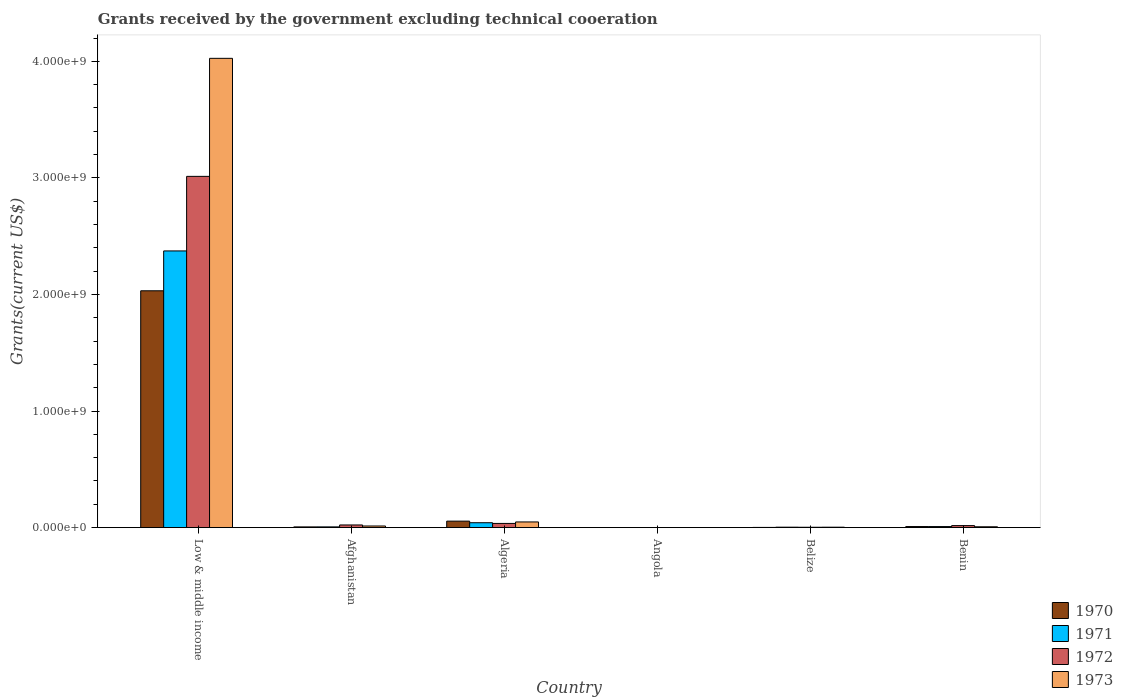How many groups of bars are there?
Ensure brevity in your answer.  6. Are the number of bars per tick equal to the number of legend labels?
Provide a succinct answer. Yes. Are the number of bars on each tick of the X-axis equal?
Your answer should be compact. Yes. How many bars are there on the 3rd tick from the left?
Keep it short and to the point. 4. What is the label of the 3rd group of bars from the left?
Give a very brief answer. Algeria. In how many cases, is the number of bars for a given country not equal to the number of legend labels?
Give a very brief answer. 0. What is the total grants received by the government in 1970 in Belize?
Make the answer very short. 1.77e+06. Across all countries, what is the maximum total grants received by the government in 1972?
Your answer should be compact. 3.01e+09. In which country was the total grants received by the government in 1971 maximum?
Your response must be concise. Low & middle income. In which country was the total grants received by the government in 1971 minimum?
Your answer should be very brief. Angola. What is the total total grants received by the government in 1971 in the graph?
Ensure brevity in your answer.  2.43e+09. What is the difference between the total grants received by the government in 1972 in Angola and that in Benin?
Make the answer very short. -1.73e+07. What is the difference between the total grants received by the government in 1970 in Low & middle income and the total grants received by the government in 1971 in Algeria?
Offer a terse response. 1.99e+09. What is the average total grants received by the government in 1973 per country?
Your answer should be very brief. 6.83e+08. What is the difference between the total grants received by the government of/in 1973 and total grants received by the government of/in 1971 in Belize?
Your response must be concise. -1.30e+05. In how many countries, is the total grants received by the government in 1973 greater than 1000000000 US$?
Offer a terse response. 1. What is the ratio of the total grants received by the government in 1973 in Afghanistan to that in Benin?
Your response must be concise. 1.93. Is the difference between the total grants received by the government in 1973 in Afghanistan and Belize greater than the difference between the total grants received by the government in 1971 in Afghanistan and Belize?
Offer a very short reply. Yes. What is the difference between the highest and the second highest total grants received by the government in 1973?
Your answer should be compact. 4.01e+09. What is the difference between the highest and the lowest total grants received by the government in 1970?
Make the answer very short. 2.03e+09. Is it the case that in every country, the sum of the total grants received by the government in 1973 and total grants received by the government in 1970 is greater than the sum of total grants received by the government in 1972 and total grants received by the government in 1971?
Your response must be concise. No. What does the 3rd bar from the left in Angola represents?
Provide a short and direct response. 1972. Is it the case that in every country, the sum of the total grants received by the government in 1970 and total grants received by the government in 1971 is greater than the total grants received by the government in 1973?
Make the answer very short. No. How many countries are there in the graph?
Your response must be concise. 6. Where does the legend appear in the graph?
Your answer should be compact. Bottom right. How are the legend labels stacked?
Make the answer very short. Vertical. What is the title of the graph?
Your answer should be compact. Grants received by the government excluding technical cooeration. What is the label or title of the Y-axis?
Provide a succinct answer. Grants(current US$). What is the Grants(current US$) of 1970 in Low & middle income?
Your answer should be compact. 2.03e+09. What is the Grants(current US$) of 1971 in Low & middle income?
Make the answer very short. 2.37e+09. What is the Grants(current US$) of 1972 in Low & middle income?
Offer a terse response. 3.01e+09. What is the Grants(current US$) of 1973 in Low & middle income?
Give a very brief answer. 4.03e+09. What is the Grants(current US$) in 1970 in Afghanistan?
Your response must be concise. 6.21e+06. What is the Grants(current US$) of 1971 in Afghanistan?
Your answer should be very brief. 6.32e+06. What is the Grants(current US$) of 1972 in Afghanistan?
Offer a terse response. 2.29e+07. What is the Grants(current US$) of 1973 in Afghanistan?
Your answer should be compact. 1.40e+07. What is the Grants(current US$) of 1970 in Algeria?
Offer a terse response. 5.56e+07. What is the Grants(current US$) in 1971 in Algeria?
Give a very brief answer. 4.21e+07. What is the Grants(current US$) of 1972 in Algeria?
Make the answer very short. 3.60e+07. What is the Grants(current US$) of 1973 in Algeria?
Your response must be concise. 4.88e+07. What is the Grants(current US$) of 1970 in Angola?
Provide a succinct answer. 2.00e+04. What is the Grants(current US$) of 1972 in Angola?
Give a very brief answer. 3.00e+04. What is the Grants(current US$) of 1970 in Belize?
Your answer should be very brief. 1.77e+06. What is the Grants(current US$) of 1971 in Belize?
Offer a terse response. 3.75e+06. What is the Grants(current US$) in 1972 in Belize?
Offer a terse response. 3.09e+06. What is the Grants(current US$) in 1973 in Belize?
Make the answer very short. 3.62e+06. What is the Grants(current US$) in 1970 in Benin?
Provide a short and direct response. 9.23e+06. What is the Grants(current US$) of 1971 in Benin?
Make the answer very short. 9.04e+06. What is the Grants(current US$) of 1972 in Benin?
Your answer should be very brief. 1.73e+07. What is the Grants(current US$) in 1973 in Benin?
Your answer should be very brief. 7.26e+06. Across all countries, what is the maximum Grants(current US$) of 1970?
Your response must be concise. 2.03e+09. Across all countries, what is the maximum Grants(current US$) of 1971?
Your answer should be very brief. 2.37e+09. Across all countries, what is the maximum Grants(current US$) of 1972?
Ensure brevity in your answer.  3.01e+09. Across all countries, what is the maximum Grants(current US$) in 1973?
Ensure brevity in your answer.  4.03e+09. Across all countries, what is the minimum Grants(current US$) of 1971?
Your answer should be very brief. 10000. Across all countries, what is the minimum Grants(current US$) in 1972?
Your answer should be very brief. 3.00e+04. Across all countries, what is the minimum Grants(current US$) of 1973?
Provide a short and direct response. 8.00e+04. What is the total Grants(current US$) in 1970 in the graph?
Your answer should be very brief. 2.10e+09. What is the total Grants(current US$) in 1971 in the graph?
Your answer should be very brief. 2.43e+09. What is the total Grants(current US$) of 1972 in the graph?
Your answer should be compact. 3.09e+09. What is the total Grants(current US$) in 1973 in the graph?
Give a very brief answer. 4.10e+09. What is the difference between the Grants(current US$) in 1970 in Low & middle income and that in Afghanistan?
Keep it short and to the point. 2.03e+09. What is the difference between the Grants(current US$) in 1971 in Low & middle income and that in Afghanistan?
Your response must be concise. 2.37e+09. What is the difference between the Grants(current US$) of 1972 in Low & middle income and that in Afghanistan?
Keep it short and to the point. 2.99e+09. What is the difference between the Grants(current US$) in 1973 in Low & middle income and that in Afghanistan?
Provide a short and direct response. 4.01e+09. What is the difference between the Grants(current US$) in 1970 in Low & middle income and that in Algeria?
Your answer should be very brief. 1.98e+09. What is the difference between the Grants(current US$) of 1971 in Low & middle income and that in Algeria?
Your answer should be compact. 2.33e+09. What is the difference between the Grants(current US$) of 1972 in Low & middle income and that in Algeria?
Ensure brevity in your answer.  2.98e+09. What is the difference between the Grants(current US$) in 1973 in Low & middle income and that in Algeria?
Provide a succinct answer. 3.98e+09. What is the difference between the Grants(current US$) in 1970 in Low & middle income and that in Angola?
Offer a very short reply. 2.03e+09. What is the difference between the Grants(current US$) in 1971 in Low & middle income and that in Angola?
Give a very brief answer. 2.37e+09. What is the difference between the Grants(current US$) in 1972 in Low & middle income and that in Angola?
Your answer should be very brief. 3.01e+09. What is the difference between the Grants(current US$) in 1973 in Low & middle income and that in Angola?
Offer a very short reply. 4.03e+09. What is the difference between the Grants(current US$) in 1970 in Low & middle income and that in Belize?
Provide a succinct answer. 2.03e+09. What is the difference between the Grants(current US$) of 1971 in Low & middle income and that in Belize?
Provide a short and direct response. 2.37e+09. What is the difference between the Grants(current US$) in 1972 in Low & middle income and that in Belize?
Provide a short and direct response. 3.01e+09. What is the difference between the Grants(current US$) in 1973 in Low & middle income and that in Belize?
Keep it short and to the point. 4.02e+09. What is the difference between the Grants(current US$) of 1970 in Low & middle income and that in Benin?
Offer a terse response. 2.02e+09. What is the difference between the Grants(current US$) in 1971 in Low & middle income and that in Benin?
Ensure brevity in your answer.  2.36e+09. What is the difference between the Grants(current US$) in 1972 in Low & middle income and that in Benin?
Ensure brevity in your answer.  3.00e+09. What is the difference between the Grants(current US$) of 1973 in Low & middle income and that in Benin?
Provide a succinct answer. 4.02e+09. What is the difference between the Grants(current US$) in 1970 in Afghanistan and that in Algeria?
Provide a succinct answer. -4.94e+07. What is the difference between the Grants(current US$) in 1971 in Afghanistan and that in Algeria?
Your response must be concise. -3.58e+07. What is the difference between the Grants(current US$) of 1972 in Afghanistan and that in Algeria?
Your answer should be compact. -1.31e+07. What is the difference between the Grants(current US$) of 1973 in Afghanistan and that in Algeria?
Your answer should be compact. -3.47e+07. What is the difference between the Grants(current US$) in 1970 in Afghanistan and that in Angola?
Provide a succinct answer. 6.19e+06. What is the difference between the Grants(current US$) in 1971 in Afghanistan and that in Angola?
Your response must be concise. 6.31e+06. What is the difference between the Grants(current US$) in 1972 in Afghanistan and that in Angola?
Give a very brief answer. 2.29e+07. What is the difference between the Grants(current US$) of 1973 in Afghanistan and that in Angola?
Provide a succinct answer. 1.40e+07. What is the difference between the Grants(current US$) in 1970 in Afghanistan and that in Belize?
Provide a short and direct response. 4.44e+06. What is the difference between the Grants(current US$) in 1971 in Afghanistan and that in Belize?
Offer a very short reply. 2.57e+06. What is the difference between the Grants(current US$) in 1972 in Afghanistan and that in Belize?
Make the answer very short. 1.98e+07. What is the difference between the Grants(current US$) in 1973 in Afghanistan and that in Belize?
Your answer should be very brief. 1.04e+07. What is the difference between the Grants(current US$) of 1970 in Afghanistan and that in Benin?
Your answer should be very brief. -3.02e+06. What is the difference between the Grants(current US$) in 1971 in Afghanistan and that in Benin?
Provide a succinct answer. -2.72e+06. What is the difference between the Grants(current US$) in 1972 in Afghanistan and that in Benin?
Offer a very short reply. 5.57e+06. What is the difference between the Grants(current US$) in 1973 in Afghanistan and that in Benin?
Your answer should be very brief. 6.78e+06. What is the difference between the Grants(current US$) in 1970 in Algeria and that in Angola?
Your answer should be very brief. 5.56e+07. What is the difference between the Grants(current US$) of 1971 in Algeria and that in Angola?
Offer a very short reply. 4.21e+07. What is the difference between the Grants(current US$) in 1972 in Algeria and that in Angola?
Offer a terse response. 3.59e+07. What is the difference between the Grants(current US$) of 1973 in Algeria and that in Angola?
Offer a very short reply. 4.87e+07. What is the difference between the Grants(current US$) of 1970 in Algeria and that in Belize?
Make the answer very short. 5.38e+07. What is the difference between the Grants(current US$) of 1971 in Algeria and that in Belize?
Provide a succinct answer. 3.83e+07. What is the difference between the Grants(current US$) in 1972 in Algeria and that in Belize?
Your answer should be compact. 3.29e+07. What is the difference between the Grants(current US$) of 1973 in Algeria and that in Belize?
Keep it short and to the point. 4.52e+07. What is the difference between the Grants(current US$) of 1970 in Algeria and that in Benin?
Offer a very short reply. 4.64e+07. What is the difference between the Grants(current US$) in 1971 in Algeria and that in Benin?
Give a very brief answer. 3.30e+07. What is the difference between the Grants(current US$) in 1972 in Algeria and that in Benin?
Offer a terse response. 1.86e+07. What is the difference between the Grants(current US$) of 1973 in Algeria and that in Benin?
Offer a very short reply. 4.15e+07. What is the difference between the Grants(current US$) of 1970 in Angola and that in Belize?
Offer a terse response. -1.75e+06. What is the difference between the Grants(current US$) in 1971 in Angola and that in Belize?
Offer a terse response. -3.74e+06. What is the difference between the Grants(current US$) in 1972 in Angola and that in Belize?
Ensure brevity in your answer.  -3.06e+06. What is the difference between the Grants(current US$) of 1973 in Angola and that in Belize?
Provide a short and direct response. -3.54e+06. What is the difference between the Grants(current US$) of 1970 in Angola and that in Benin?
Ensure brevity in your answer.  -9.21e+06. What is the difference between the Grants(current US$) of 1971 in Angola and that in Benin?
Provide a short and direct response. -9.03e+06. What is the difference between the Grants(current US$) in 1972 in Angola and that in Benin?
Keep it short and to the point. -1.73e+07. What is the difference between the Grants(current US$) in 1973 in Angola and that in Benin?
Your response must be concise. -7.18e+06. What is the difference between the Grants(current US$) of 1970 in Belize and that in Benin?
Provide a succinct answer. -7.46e+06. What is the difference between the Grants(current US$) of 1971 in Belize and that in Benin?
Make the answer very short. -5.29e+06. What is the difference between the Grants(current US$) of 1972 in Belize and that in Benin?
Give a very brief answer. -1.42e+07. What is the difference between the Grants(current US$) of 1973 in Belize and that in Benin?
Provide a succinct answer. -3.64e+06. What is the difference between the Grants(current US$) of 1970 in Low & middle income and the Grants(current US$) of 1971 in Afghanistan?
Give a very brief answer. 2.03e+09. What is the difference between the Grants(current US$) of 1970 in Low & middle income and the Grants(current US$) of 1972 in Afghanistan?
Your answer should be very brief. 2.01e+09. What is the difference between the Grants(current US$) of 1970 in Low & middle income and the Grants(current US$) of 1973 in Afghanistan?
Give a very brief answer. 2.02e+09. What is the difference between the Grants(current US$) of 1971 in Low & middle income and the Grants(current US$) of 1972 in Afghanistan?
Give a very brief answer. 2.35e+09. What is the difference between the Grants(current US$) of 1971 in Low & middle income and the Grants(current US$) of 1973 in Afghanistan?
Ensure brevity in your answer.  2.36e+09. What is the difference between the Grants(current US$) in 1972 in Low & middle income and the Grants(current US$) in 1973 in Afghanistan?
Your answer should be very brief. 3.00e+09. What is the difference between the Grants(current US$) in 1970 in Low & middle income and the Grants(current US$) in 1971 in Algeria?
Keep it short and to the point. 1.99e+09. What is the difference between the Grants(current US$) in 1970 in Low & middle income and the Grants(current US$) in 1972 in Algeria?
Make the answer very short. 2.00e+09. What is the difference between the Grants(current US$) of 1970 in Low & middle income and the Grants(current US$) of 1973 in Algeria?
Ensure brevity in your answer.  1.98e+09. What is the difference between the Grants(current US$) in 1971 in Low & middle income and the Grants(current US$) in 1972 in Algeria?
Your response must be concise. 2.34e+09. What is the difference between the Grants(current US$) in 1971 in Low & middle income and the Grants(current US$) in 1973 in Algeria?
Ensure brevity in your answer.  2.32e+09. What is the difference between the Grants(current US$) of 1972 in Low & middle income and the Grants(current US$) of 1973 in Algeria?
Your answer should be compact. 2.96e+09. What is the difference between the Grants(current US$) in 1970 in Low & middle income and the Grants(current US$) in 1971 in Angola?
Provide a succinct answer. 2.03e+09. What is the difference between the Grants(current US$) in 1970 in Low & middle income and the Grants(current US$) in 1972 in Angola?
Your response must be concise. 2.03e+09. What is the difference between the Grants(current US$) in 1970 in Low & middle income and the Grants(current US$) in 1973 in Angola?
Give a very brief answer. 2.03e+09. What is the difference between the Grants(current US$) in 1971 in Low & middle income and the Grants(current US$) in 1972 in Angola?
Offer a very short reply. 2.37e+09. What is the difference between the Grants(current US$) of 1971 in Low & middle income and the Grants(current US$) of 1973 in Angola?
Your answer should be very brief. 2.37e+09. What is the difference between the Grants(current US$) of 1972 in Low & middle income and the Grants(current US$) of 1973 in Angola?
Your answer should be compact. 3.01e+09. What is the difference between the Grants(current US$) in 1970 in Low & middle income and the Grants(current US$) in 1971 in Belize?
Your answer should be compact. 2.03e+09. What is the difference between the Grants(current US$) in 1970 in Low & middle income and the Grants(current US$) in 1972 in Belize?
Keep it short and to the point. 2.03e+09. What is the difference between the Grants(current US$) of 1970 in Low & middle income and the Grants(current US$) of 1973 in Belize?
Give a very brief answer. 2.03e+09. What is the difference between the Grants(current US$) of 1971 in Low & middle income and the Grants(current US$) of 1972 in Belize?
Ensure brevity in your answer.  2.37e+09. What is the difference between the Grants(current US$) of 1971 in Low & middle income and the Grants(current US$) of 1973 in Belize?
Your response must be concise. 2.37e+09. What is the difference between the Grants(current US$) in 1972 in Low & middle income and the Grants(current US$) in 1973 in Belize?
Your answer should be compact. 3.01e+09. What is the difference between the Grants(current US$) of 1970 in Low & middle income and the Grants(current US$) of 1971 in Benin?
Provide a short and direct response. 2.02e+09. What is the difference between the Grants(current US$) in 1970 in Low & middle income and the Grants(current US$) in 1972 in Benin?
Your response must be concise. 2.01e+09. What is the difference between the Grants(current US$) in 1970 in Low & middle income and the Grants(current US$) in 1973 in Benin?
Provide a short and direct response. 2.02e+09. What is the difference between the Grants(current US$) in 1971 in Low & middle income and the Grants(current US$) in 1972 in Benin?
Your answer should be very brief. 2.36e+09. What is the difference between the Grants(current US$) of 1971 in Low & middle income and the Grants(current US$) of 1973 in Benin?
Offer a very short reply. 2.37e+09. What is the difference between the Grants(current US$) in 1972 in Low & middle income and the Grants(current US$) in 1973 in Benin?
Offer a very short reply. 3.01e+09. What is the difference between the Grants(current US$) of 1970 in Afghanistan and the Grants(current US$) of 1971 in Algeria?
Offer a very short reply. -3.59e+07. What is the difference between the Grants(current US$) in 1970 in Afghanistan and the Grants(current US$) in 1972 in Algeria?
Your answer should be very brief. -2.98e+07. What is the difference between the Grants(current US$) of 1970 in Afghanistan and the Grants(current US$) of 1973 in Algeria?
Your answer should be very brief. -4.26e+07. What is the difference between the Grants(current US$) of 1971 in Afghanistan and the Grants(current US$) of 1972 in Algeria?
Give a very brief answer. -2.96e+07. What is the difference between the Grants(current US$) of 1971 in Afghanistan and the Grants(current US$) of 1973 in Algeria?
Your answer should be very brief. -4.24e+07. What is the difference between the Grants(current US$) of 1972 in Afghanistan and the Grants(current US$) of 1973 in Algeria?
Offer a terse response. -2.59e+07. What is the difference between the Grants(current US$) of 1970 in Afghanistan and the Grants(current US$) of 1971 in Angola?
Offer a terse response. 6.20e+06. What is the difference between the Grants(current US$) in 1970 in Afghanistan and the Grants(current US$) in 1972 in Angola?
Provide a short and direct response. 6.18e+06. What is the difference between the Grants(current US$) in 1970 in Afghanistan and the Grants(current US$) in 1973 in Angola?
Your response must be concise. 6.13e+06. What is the difference between the Grants(current US$) of 1971 in Afghanistan and the Grants(current US$) of 1972 in Angola?
Ensure brevity in your answer.  6.29e+06. What is the difference between the Grants(current US$) of 1971 in Afghanistan and the Grants(current US$) of 1973 in Angola?
Give a very brief answer. 6.24e+06. What is the difference between the Grants(current US$) of 1972 in Afghanistan and the Grants(current US$) of 1973 in Angola?
Give a very brief answer. 2.28e+07. What is the difference between the Grants(current US$) in 1970 in Afghanistan and the Grants(current US$) in 1971 in Belize?
Keep it short and to the point. 2.46e+06. What is the difference between the Grants(current US$) in 1970 in Afghanistan and the Grants(current US$) in 1972 in Belize?
Your answer should be very brief. 3.12e+06. What is the difference between the Grants(current US$) of 1970 in Afghanistan and the Grants(current US$) of 1973 in Belize?
Offer a very short reply. 2.59e+06. What is the difference between the Grants(current US$) in 1971 in Afghanistan and the Grants(current US$) in 1972 in Belize?
Provide a succinct answer. 3.23e+06. What is the difference between the Grants(current US$) in 1971 in Afghanistan and the Grants(current US$) in 1973 in Belize?
Provide a succinct answer. 2.70e+06. What is the difference between the Grants(current US$) in 1972 in Afghanistan and the Grants(current US$) in 1973 in Belize?
Offer a very short reply. 1.93e+07. What is the difference between the Grants(current US$) in 1970 in Afghanistan and the Grants(current US$) in 1971 in Benin?
Provide a short and direct response. -2.83e+06. What is the difference between the Grants(current US$) of 1970 in Afghanistan and the Grants(current US$) of 1972 in Benin?
Make the answer very short. -1.11e+07. What is the difference between the Grants(current US$) of 1970 in Afghanistan and the Grants(current US$) of 1973 in Benin?
Your response must be concise. -1.05e+06. What is the difference between the Grants(current US$) in 1971 in Afghanistan and the Grants(current US$) in 1972 in Benin?
Keep it short and to the point. -1.10e+07. What is the difference between the Grants(current US$) of 1971 in Afghanistan and the Grants(current US$) of 1973 in Benin?
Give a very brief answer. -9.40e+05. What is the difference between the Grants(current US$) of 1972 in Afghanistan and the Grants(current US$) of 1973 in Benin?
Keep it short and to the point. 1.56e+07. What is the difference between the Grants(current US$) of 1970 in Algeria and the Grants(current US$) of 1971 in Angola?
Make the answer very short. 5.56e+07. What is the difference between the Grants(current US$) in 1970 in Algeria and the Grants(current US$) in 1972 in Angola?
Give a very brief answer. 5.56e+07. What is the difference between the Grants(current US$) in 1970 in Algeria and the Grants(current US$) in 1973 in Angola?
Make the answer very short. 5.55e+07. What is the difference between the Grants(current US$) in 1971 in Algeria and the Grants(current US$) in 1972 in Angola?
Your response must be concise. 4.20e+07. What is the difference between the Grants(current US$) in 1971 in Algeria and the Grants(current US$) in 1973 in Angola?
Your response must be concise. 4.20e+07. What is the difference between the Grants(current US$) of 1972 in Algeria and the Grants(current US$) of 1973 in Angola?
Your answer should be very brief. 3.59e+07. What is the difference between the Grants(current US$) in 1970 in Algeria and the Grants(current US$) in 1971 in Belize?
Keep it short and to the point. 5.19e+07. What is the difference between the Grants(current US$) of 1970 in Algeria and the Grants(current US$) of 1972 in Belize?
Keep it short and to the point. 5.25e+07. What is the difference between the Grants(current US$) of 1970 in Algeria and the Grants(current US$) of 1973 in Belize?
Keep it short and to the point. 5.20e+07. What is the difference between the Grants(current US$) of 1971 in Algeria and the Grants(current US$) of 1972 in Belize?
Give a very brief answer. 3.90e+07. What is the difference between the Grants(current US$) in 1971 in Algeria and the Grants(current US$) in 1973 in Belize?
Ensure brevity in your answer.  3.85e+07. What is the difference between the Grants(current US$) in 1972 in Algeria and the Grants(current US$) in 1973 in Belize?
Offer a very short reply. 3.23e+07. What is the difference between the Grants(current US$) of 1970 in Algeria and the Grants(current US$) of 1971 in Benin?
Give a very brief answer. 4.66e+07. What is the difference between the Grants(current US$) in 1970 in Algeria and the Grants(current US$) in 1972 in Benin?
Your response must be concise. 3.83e+07. What is the difference between the Grants(current US$) in 1970 in Algeria and the Grants(current US$) in 1973 in Benin?
Provide a succinct answer. 4.84e+07. What is the difference between the Grants(current US$) in 1971 in Algeria and the Grants(current US$) in 1972 in Benin?
Provide a succinct answer. 2.48e+07. What is the difference between the Grants(current US$) in 1971 in Algeria and the Grants(current US$) in 1973 in Benin?
Ensure brevity in your answer.  3.48e+07. What is the difference between the Grants(current US$) of 1972 in Algeria and the Grants(current US$) of 1973 in Benin?
Your response must be concise. 2.87e+07. What is the difference between the Grants(current US$) in 1970 in Angola and the Grants(current US$) in 1971 in Belize?
Give a very brief answer. -3.73e+06. What is the difference between the Grants(current US$) in 1970 in Angola and the Grants(current US$) in 1972 in Belize?
Your answer should be compact. -3.07e+06. What is the difference between the Grants(current US$) of 1970 in Angola and the Grants(current US$) of 1973 in Belize?
Provide a short and direct response. -3.60e+06. What is the difference between the Grants(current US$) of 1971 in Angola and the Grants(current US$) of 1972 in Belize?
Give a very brief answer. -3.08e+06. What is the difference between the Grants(current US$) of 1971 in Angola and the Grants(current US$) of 1973 in Belize?
Ensure brevity in your answer.  -3.61e+06. What is the difference between the Grants(current US$) in 1972 in Angola and the Grants(current US$) in 1973 in Belize?
Provide a short and direct response. -3.59e+06. What is the difference between the Grants(current US$) in 1970 in Angola and the Grants(current US$) in 1971 in Benin?
Provide a short and direct response. -9.02e+06. What is the difference between the Grants(current US$) in 1970 in Angola and the Grants(current US$) in 1972 in Benin?
Offer a very short reply. -1.73e+07. What is the difference between the Grants(current US$) of 1970 in Angola and the Grants(current US$) of 1973 in Benin?
Your answer should be very brief. -7.24e+06. What is the difference between the Grants(current US$) in 1971 in Angola and the Grants(current US$) in 1972 in Benin?
Provide a short and direct response. -1.73e+07. What is the difference between the Grants(current US$) of 1971 in Angola and the Grants(current US$) of 1973 in Benin?
Provide a short and direct response. -7.25e+06. What is the difference between the Grants(current US$) in 1972 in Angola and the Grants(current US$) in 1973 in Benin?
Your answer should be very brief. -7.23e+06. What is the difference between the Grants(current US$) in 1970 in Belize and the Grants(current US$) in 1971 in Benin?
Give a very brief answer. -7.27e+06. What is the difference between the Grants(current US$) of 1970 in Belize and the Grants(current US$) of 1972 in Benin?
Provide a succinct answer. -1.56e+07. What is the difference between the Grants(current US$) of 1970 in Belize and the Grants(current US$) of 1973 in Benin?
Give a very brief answer. -5.49e+06. What is the difference between the Grants(current US$) in 1971 in Belize and the Grants(current US$) in 1972 in Benin?
Your answer should be very brief. -1.36e+07. What is the difference between the Grants(current US$) of 1971 in Belize and the Grants(current US$) of 1973 in Benin?
Your response must be concise. -3.51e+06. What is the difference between the Grants(current US$) in 1972 in Belize and the Grants(current US$) in 1973 in Benin?
Give a very brief answer. -4.17e+06. What is the average Grants(current US$) in 1970 per country?
Your answer should be compact. 3.51e+08. What is the average Grants(current US$) of 1971 per country?
Offer a very short reply. 4.06e+08. What is the average Grants(current US$) in 1972 per country?
Give a very brief answer. 5.15e+08. What is the average Grants(current US$) in 1973 per country?
Your answer should be very brief. 6.83e+08. What is the difference between the Grants(current US$) of 1970 and Grants(current US$) of 1971 in Low & middle income?
Ensure brevity in your answer.  -3.42e+08. What is the difference between the Grants(current US$) of 1970 and Grants(current US$) of 1972 in Low & middle income?
Your response must be concise. -9.82e+08. What is the difference between the Grants(current US$) of 1970 and Grants(current US$) of 1973 in Low & middle income?
Ensure brevity in your answer.  -1.99e+09. What is the difference between the Grants(current US$) of 1971 and Grants(current US$) of 1972 in Low & middle income?
Keep it short and to the point. -6.40e+08. What is the difference between the Grants(current US$) of 1971 and Grants(current US$) of 1973 in Low & middle income?
Your answer should be very brief. -1.65e+09. What is the difference between the Grants(current US$) of 1972 and Grants(current US$) of 1973 in Low & middle income?
Ensure brevity in your answer.  -1.01e+09. What is the difference between the Grants(current US$) of 1970 and Grants(current US$) of 1971 in Afghanistan?
Provide a short and direct response. -1.10e+05. What is the difference between the Grants(current US$) in 1970 and Grants(current US$) in 1972 in Afghanistan?
Offer a terse response. -1.67e+07. What is the difference between the Grants(current US$) in 1970 and Grants(current US$) in 1973 in Afghanistan?
Ensure brevity in your answer.  -7.83e+06. What is the difference between the Grants(current US$) in 1971 and Grants(current US$) in 1972 in Afghanistan?
Keep it short and to the point. -1.66e+07. What is the difference between the Grants(current US$) of 1971 and Grants(current US$) of 1973 in Afghanistan?
Keep it short and to the point. -7.72e+06. What is the difference between the Grants(current US$) of 1972 and Grants(current US$) of 1973 in Afghanistan?
Provide a short and direct response. 8.85e+06. What is the difference between the Grants(current US$) in 1970 and Grants(current US$) in 1971 in Algeria?
Your answer should be very brief. 1.35e+07. What is the difference between the Grants(current US$) of 1970 and Grants(current US$) of 1972 in Algeria?
Your answer should be very brief. 1.97e+07. What is the difference between the Grants(current US$) of 1970 and Grants(current US$) of 1973 in Algeria?
Give a very brief answer. 6.85e+06. What is the difference between the Grants(current US$) in 1971 and Grants(current US$) in 1972 in Algeria?
Provide a short and direct response. 6.12e+06. What is the difference between the Grants(current US$) of 1971 and Grants(current US$) of 1973 in Algeria?
Keep it short and to the point. -6.69e+06. What is the difference between the Grants(current US$) in 1972 and Grants(current US$) in 1973 in Algeria?
Keep it short and to the point. -1.28e+07. What is the difference between the Grants(current US$) of 1970 and Grants(current US$) of 1971 in Angola?
Your response must be concise. 10000. What is the difference between the Grants(current US$) in 1970 and Grants(current US$) in 1972 in Angola?
Give a very brief answer. -10000. What is the difference between the Grants(current US$) in 1970 and Grants(current US$) in 1973 in Angola?
Give a very brief answer. -6.00e+04. What is the difference between the Grants(current US$) of 1971 and Grants(current US$) of 1972 in Angola?
Provide a succinct answer. -2.00e+04. What is the difference between the Grants(current US$) of 1971 and Grants(current US$) of 1973 in Angola?
Offer a very short reply. -7.00e+04. What is the difference between the Grants(current US$) in 1972 and Grants(current US$) in 1973 in Angola?
Make the answer very short. -5.00e+04. What is the difference between the Grants(current US$) in 1970 and Grants(current US$) in 1971 in Belize?
Ensure brevity in your answer.  -1.98e+06. What is the difference between the Grants(current US$) of 1970 and Grants(current US$) of 1972 in Belize?
Your answer should be very brief. -1.32e+06. What is the difference between the Grants(current US$) of 1970 and Grants(current US$) of 1973 in Belize?
Provide a succinct answer. -1.85e+06. What is the difference between the Grants(current US$) of 1971 and Grants(current US$) of 1973 in Belize?
Give a very brief answer. 1.30e+05. What is the difference between the Grants(current US$) of 1972 and Grants(current US$) of 1973 in Belize?
Make the answer very short. -5.30e+05. What is the difference between the Grants(current US$) in 1970 and Grants(current US$) in 1972 in Benin?
Offer a very short reply. -8.09e+06. What is the difference between the Grants(current US$) of 1970 and Grants(current US$) of 1973 in Benin?
Provide a succinct answer. 1.97e+06. What is the difference between the Grants(current US$) in 1971 and Grants(current US$) in 1972 in Benin?
Ensure brevity in your answer.  -8.28e+06. What is the difference between the Grants(current US$) of 1971 and Grants(current US$) of 1973 in Benin?
Ensure brevity in your answer.  1.78e+06. What is the difference between the Grants(current US$) of 1972 and Grants(current US$) of 1973 in Benin?
Ensure brevity in your answer.  1.01e+07. What is the ratio of the Grants(current US$) in 1970 in Low & middle income to that in Afghanistan?
Your response must be concise. 327.15. What is the ratio of the Grants(current US$) of 1971 in Low & middle income to that in Afghanistan?
Provide a short and direct response. 375.56. What is the ratio of the Grants(current US$) of 1972 in Low & middle income to that in Afghanistan?
Ensure brevity in your answer.  131.64. What is the ratio of the Grants(current US$) of 1973 in Low & middle income to that in Afghanistan?
Your response must be concise. 286.73. What is the ratio of the Grants(current US$) of 1970 in Low & middle income to that in Algeria?
Your answer should be compact. 36.53. What is the ratio of the Grants(current US$) in 1971 in Low & middle income to that in Algeria?
Offer a very short reply. 56.41. What is the ratio of the Grants(current US$) in 1972 in Low & middle income to that in Algeria?
Keep it short and to the point. 83.79. What is the ratio of the Grants(current US$) of 1973 in Low & middle income to that in Algeria?
Give a very brief answer. 82.54. What is the ratio of the Grants(current US$) in 1970 in Low & middle income to that in Angola?
Your response must be concise. 1.02e+05. What is the ratio of the Grants(current US$) of 1971 in Low & middle income to that in Angola?
Your answer should be very brief. 2.37e+05. What is the ratio of the Grants(current US$) of 1972 in Low & middle income to that in Angola?
Offer a terse response. 1.00e+05. What is the ratio of the Grants(current US$) in 1973 in Low & middle income to that in Angola?
Keep it short and to the point. 5.03e+04. What is the ratio of the Grants(current US$) of 1970 in Low & middle income to that in Belize?
Your answer should be compact. 1147.79. What is the ratio of the Grants(current US$) of 1971 in Low & middle income to that in Belize?
Provide a short and direct response. 632.94. What is the ratio of the Grants(current US$) of 1972 in Low & middle income to that in Belize?
Make the answer very short. 975.13. What is the ratio of the Grants(current US$) in 1973 in Low & middle income to that in Belize?
Offer a terse response. 1112.05. What is the ratio of the Grants(current US$) in 1970 in Low & middle income to that in Benin?
Give a very brief answer. 220.11. What is the ratio of the Grants(current US$) in 1971 in Low & middle income to that in Benin?
Make the answer very short. 262.56. What is the ratio of the Grants(current US$) in 1972 in Low & middle income to that in Benin?
Your answer should be very brief. 173.97. What is the ratio of the Grants(current US$) of 1973 in Low & middle income to that in Benin?
Ensure brevity in your answer.  554.49. What is the ratio of the Grants(current US$) in 1970 in Afghanistan to that in Algeria?
Your answer should be very brief. 0.11. What is the ratio of the Grants(current US$) of 1971 in Afghanistan to that in Algeria?
Offer a terse response. 0.15. What is the ratio of the Grants(current US$) of 1972 in Afghanistan to that in Algeria?
Offer a terse response. 0.64. What is the ratio of the Grants(current US$) in 1973 in Afghanistan to that in Algeria?
Make the answer very short. 0.29. What is the ratio of the Grants(current US$) in 1970 in Afghanistan to that in Angola?
Your answer should be compact. 310.5. What is the ratio of the Grants(current US$) in 1971 in Afghanistan to that in Angola?
Give a very brief answer. 632. What is the ratio of the Grants(current US$) in 1972 in Afghanistan to that in Angola?
Give a very brief answer. 763. What is the ratio of the Grants(current US$) in 1973 in Afghanistan to that in Angola?
Your answer should be very brief. 175.5. What is the ratio of the Grants(current US$) in 1970 in Afghanistan to that in Belize?
Offer a very short reply. 3.51. What is the ratio of the Grants(current US$) of 1971 in Afghanistan to that in Belize?
Offer a very short reply. 1.69. What is the ratio of the Grants(current US$) of 1972 in Afghanistan to that in Belize?
Give a very brief answer. 7.41. What is the ratio of the Grants(current US$) of 1973 in Afghanistan to that in Belize?
Provide a short and direct response. 3.88. What is the ratio of the Grants(current US$) of 1970 in Afghanistan to that in Benin?
Keep it short and to the point. 0.67. What is the ratio of the Grants(current US$) of 1971 in Afghanistan to that in Benin?
Give a very brief answer. 0.7. What is the ratio of the Grants(current US$) of 1972 in Afghanistan to that in Benin?
Your answer should be very brief. 1.32. What is the ratio of the Grants(current US$) of 1973 in Afghanistan to that in Benin?
Your response must be concise. 1.93. What is the ratio of the Grants(current US$) of 1970 in Algeria to that in Angola?
Your answer should be compact. 2781. What is the ratio of the Grants(current US$) in 1971 in Algeria to that in Angola?
Your answer should be compact. 4208. What is the ratio of the Grants(current US$) of 1972 in Algeria to that in Angola?
Make the answer very short. 1198.67. What is the ratio of the Grants(current US$) of 1973 in Algeria to that in Angola?
Provide a succinct answer. 609.62. What is the ratio of the Grants(current US$) of 1970 in Algeria to that in Belize?
Your answer should be compact. 31.42. What is the ratio of the Grants(current US$) in 1971 in Algeria to that in Belize?
Make the answer very short. 11.22. What is the ratio of the Grants(current US$) of 1972 in Algeria to that in Belize?
Offer a very short reply. 11.64. What is the ratio of the Grants(current US$) in 1973 in Algeria to that in Belize?
Ensure brevity in your answer.  13.47. What is the ratio of the Grants(current US$) in 1970 in Algeria to that in Benin?
Provide a succinct answer. 6.03. What is the ratio of the Grants(current US$) of 1971 in Algeria to that in Benin?
Your response must be concise. 4.65. What is the ratio of the Grants(current US$) of 1972 in Algeria to that in Benin?
Your response must be concise. 2.08. What is the ratio of the Grants(current US$) of 1973 in Algeria to that in Benin?
Your answer should be compact. 6.72. What is the ratio of the Grants(current US$) in 1970 in Angola to that in Belize?
Make the answer very short. 0.01. What is the ratio of the Grants(current US$) in 1971 in Angola to that in Belize?
Make the answer very short. 0. What is the ratio of the Grants(current US$) in 1972 in Angola to that in Belize?
Your answer should be very brief. 0.01. What is the ratio of the Grants(current US$) of 1973 in Angola to that in Belize?
Ensure brevity in your answer.  0.02. What is the ratio of the Grants(current US$) in 1970 in Angola to that in Benin?
Your answer should be compact. 0. What is the ratio of the Grants(current US$) of 1971 in Angola to that in Benin?
Your answer should be very brief. 0. What is the ratio of the Grants(current US$) of 1972 in Angola to that in Benin?
Your answer should be very brief. 0. What is the ratio of the Grants(current US$) in 1973 in Angola to that in Benin?
Provide a short and direct response. 0.01. What is the ratio of the Grants(current US$) in 1970 in Belize to that in Benin?
Make the answer very short. 0.19. What is the ratio of the Grants(current US$) of 1971 in Belize to that in Benin?
Your response must be concise. 0.41. What is the ratio of the Grants(current US$) in 1972 in Belize to that in Benin?
Your answer should be compact. 0.18. What is the ratio of the Grants(current US$) of 1973 in Belize to that in Benin?
Offer a terse response. 0.5. What is the difference between the highest and the second highest Grants(current US$) in 1970?
Keep it short and to the point. 1.98e+09. What is the difference between the highest and the second highest Grants(current US$) of 1971?
Make the answer very short. 2.33e+09. What is the difference between the highest and the second highest Grants(current US$) of 1972?
Your response must be concise. 2.98e+09. What is the difference between the highest and the second highest Grants(current US$) in 1973?
Your response must be concise. 3.98e+09. What is the difference between the highest and the lowest Grants(current US$) in 1970?
Your answer should be compact. 2.03e+09. What is the difference between the highest and the lowest Grants(current US$) of 1971?
Keep it short and to the point. 2.37e+09. What is the difference between the highest and the lowest Grants(current US$) in 1972?
Your answer should be very brief. 3.01e+09. What is the difference between the highest and the lowest Grants(current US$) in 1973?
Your answer should be very brief. 4.03e+09. 